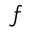Convert formula to latex. <formula><loc_0><loc_0><loc_500><loc_500>f</formula> 